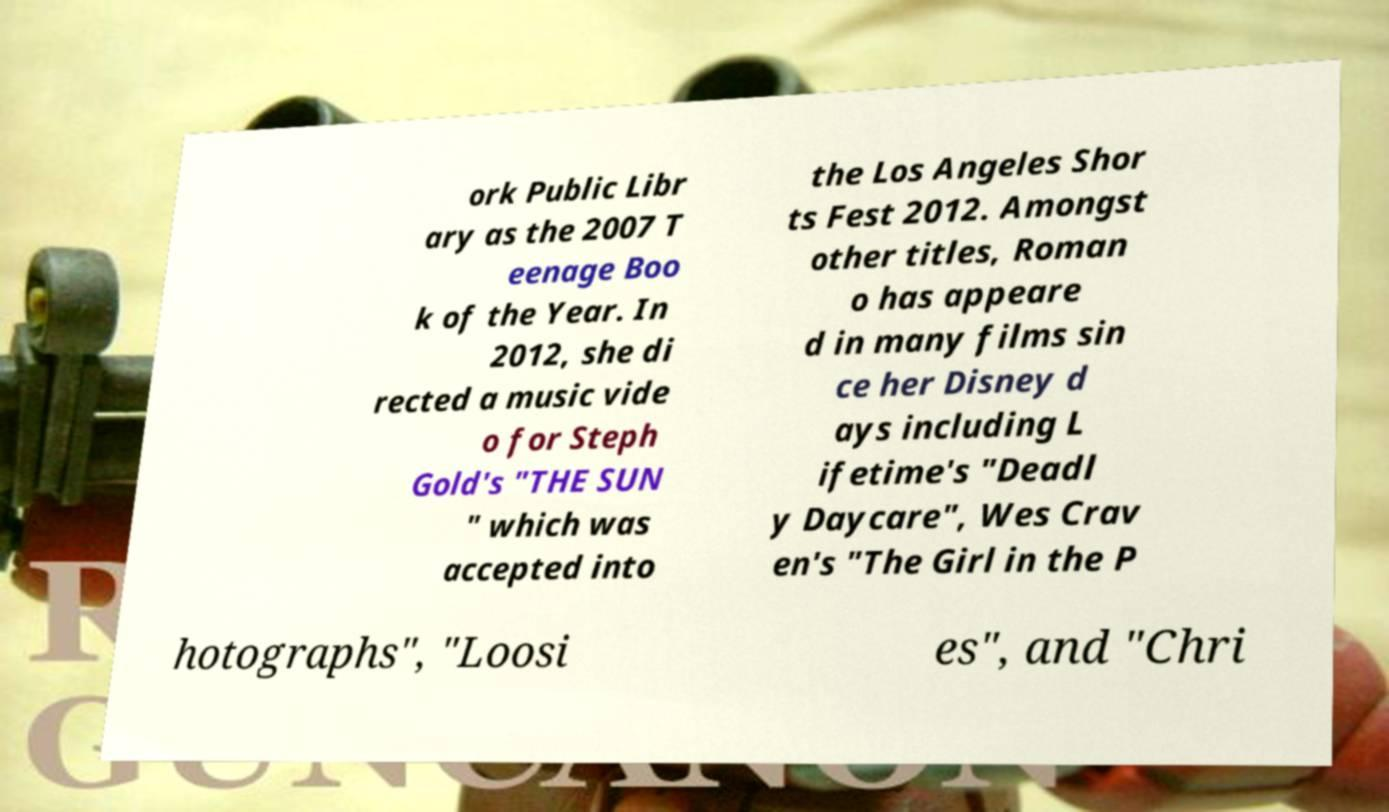Could you assist in decoding the text presented in this image and type it out clearly? ork Public Libr ary as the 2007 T eenage Boo k of the Year. In 2012, she di rected a music vide o for Steph Gold's "THE SUN " which was accepted into the Los Angeles Shor ts Fest 2012. Amongst other titles, Roman o has appeare d in many films sin ce her Disney d ays including L ifetime's "Deadl y Daycare", Wes Crav en's "The Girl in the P hotographs", "Loosi es", and "Chri 